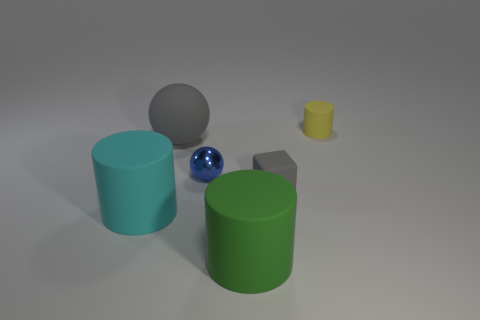There is a tiny object right of the tiny gray rubber object; what is it made of?
Your answer should be very brief. Rubber. What is the size of the thing that is the same color as the tiny matte cube?
Provide a short and direct response. Large. How many things are either yellow objects that are behind the cyan thing or large objects?
Provide a short and direct response. 4. Is the number of small things that are behind the small gray thing the same as the number of small blocks?
Offer a very short reply. No. Does the gray sphere have the same size as the metallic sphere?
Your response must be concise. No. The cylinder that is the same size as the blue metallic sphere is what color?
Ensure brevity in your answer.  Yellow. There is a blue metallic sphere; is its size the same as the matte thing that is to the left of the big gray rubber object?
Make the answer very short. No. What number of cylinders are the same color as the tiny rubber block?
Make the answer very short. 0. What number of things are gray matte balls or rubber objects left of the tiny metal object?
Give a very brief answer. 2. Do the cylinder in front of the cyan cylinder and the cylinder behind the cyan matte cylinder have the same size?
Offer a terse response. No. 